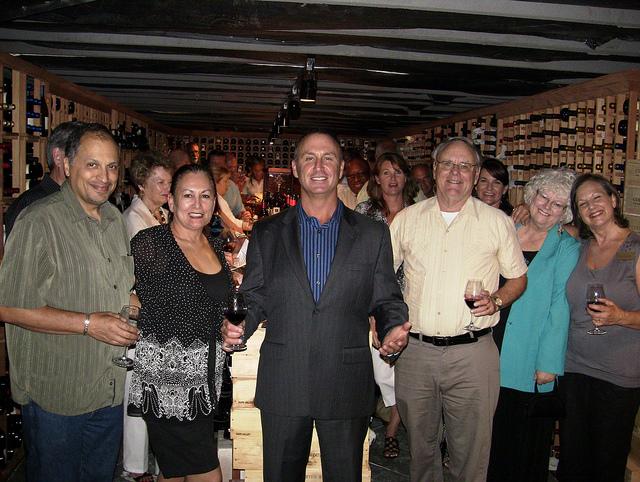What is the middle guy wearing?
Quick response, please. Suit. What is on the walls?
Concise answer only. Wine. Are all the people wearing formal clothes?
Answer briefly. No. 